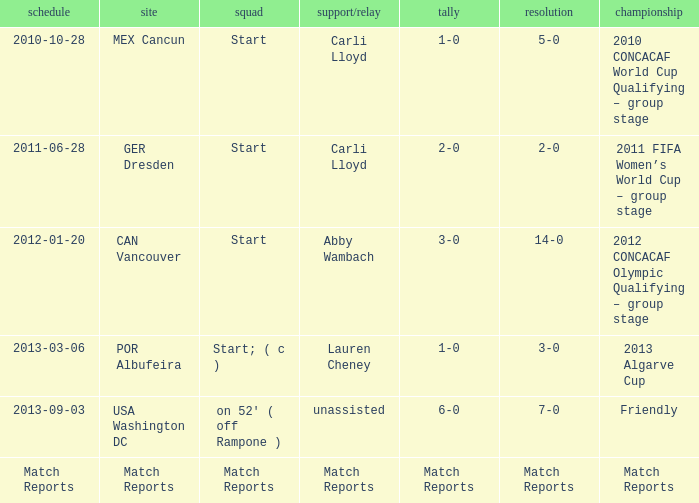Name the Lineup that has an Assist/pass of carli lloyd,a Competition of 2010 concacaf world cup qualifying – group stage? Start. 